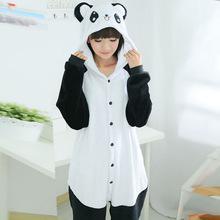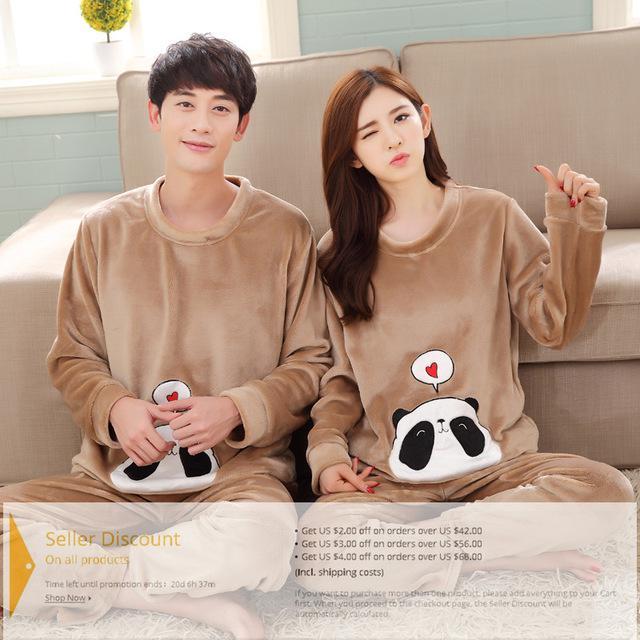The first image is the image on the left, the second image is the image on the right. Analyze the images presented: Is the assertion "In one of the image the woman has her hood pulled up." valid? Answer yes or no. Yes. The first image is the image on the left, the second image is the image on the right. Considering the images on both sides, is "Each image contains a man and a woman wearing matching clothing." valid? Answer yes or no. No. 